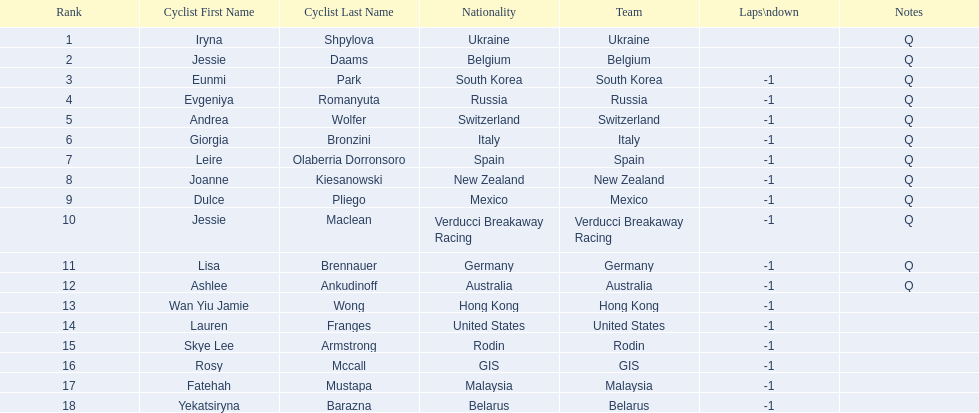Who was the first competitor to finish the race a lap behind? Eunmi Park. 